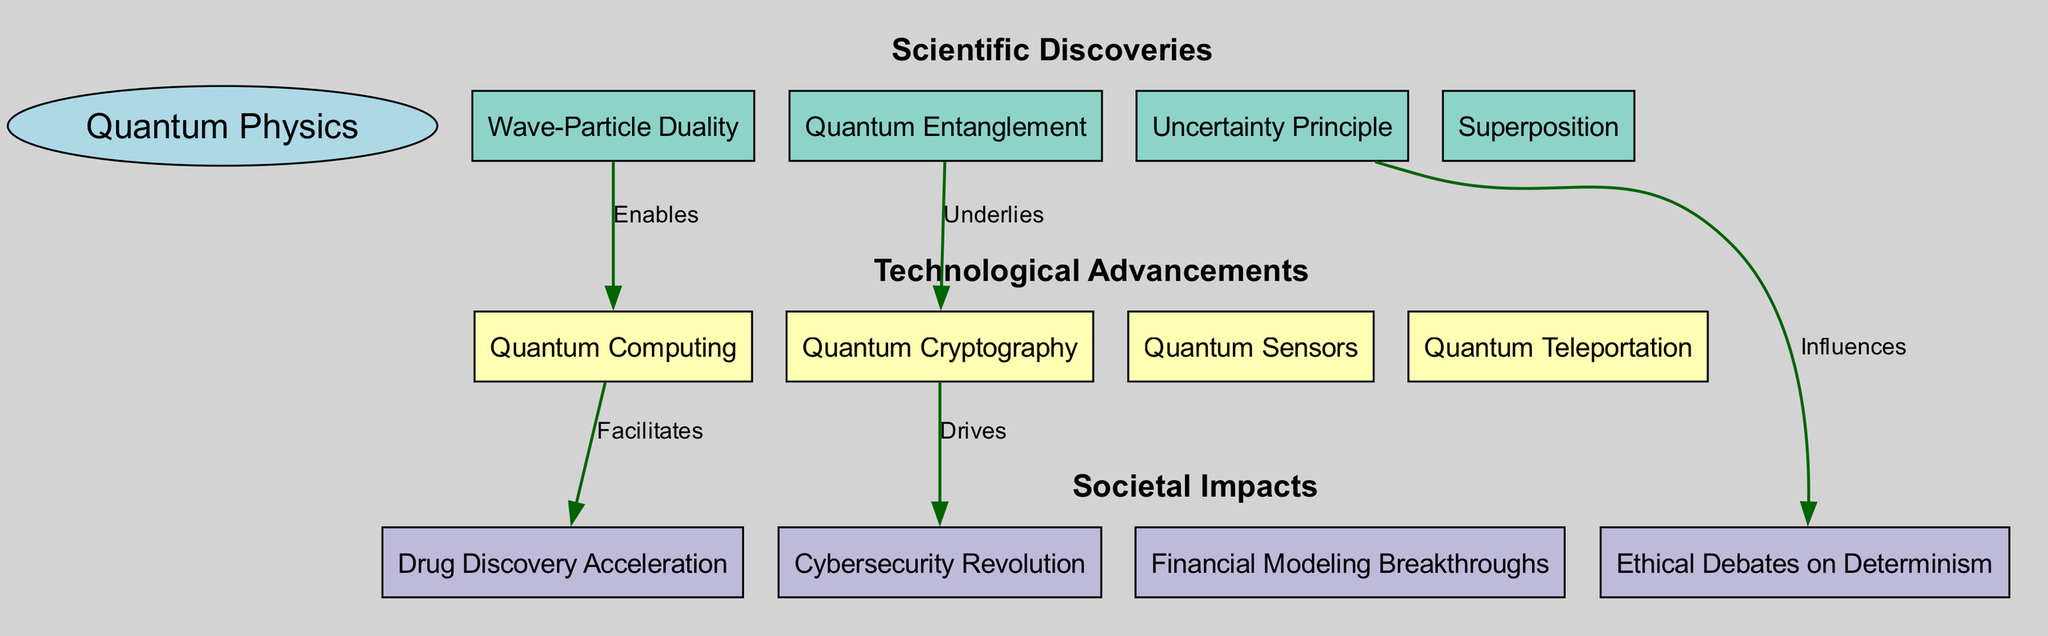What is the central concept depicted in the diagram? The central concept is labeled as "Quantum Physics" in the diagram, distinguishing it from other layers.
Answer: Quantum Physics How many nodes are there in the "Technological Advancements" layer? There are four nodes listed under the "Technological Advancements" layer: Quantum Computing, Quantum Cryptography, Quantum Sensors, and Quantum Teleportation.
Answer: Four Which discovery enables Quantum Computing? The connection from "Wave-Particle Duality" to "Quantum Computing" is labeled as "Enables," indicating that Wave-Particle Duality is the enabling scientific discovery for Quantum Computing.
Answer: Wave-Particle Duality What drives the Cybersecurity Revolution? The diagram shows an edge from "Quantum Cryptography" to "Cybersecurity Revolution" labeled as "Drives", meaning Quantum Cryptography is what drives this societal impact.
Answer: Quantum Cryptography Which principle influences ethical debates on determinism? There is a clear connection from "Uncertainty Principle" to "Ethical Debates on Determinism," indicating that the Uncertainty Principle has an influence on these debates.
Answer: Uncertainty Principle What is the relationship between Quantum Computing and Drug Discovery Acceleration? The relationship is represented by the edge from "Quantum Computing" to "Drug Discovery Acceleration," labeled as "Facilitates," which shows that Quantum Computing facilitates this societal impact.
Answer: Facilitates List two nodes in the "Scientific Discoveries" layer. The "Scientific Discoveries" layer includes the nodes "Wave-Particle Duality," "Uncertainty Principle," "Quantum Entanglement," and "Superposition." Two of these nodes can be any combination chosen, such as Wave-Particle Duality and Quantum Entanglement.
Answer: Wave-Particle Duality, Quantum Entanglement How many edges connect Scientific Discoveries to Technological Advancements? There are three edges identified that connect nodes in the "Scientific Discoveries" layer to nodes in the "Technological Advancements" layer: Wave-Particle Duality to Quantum Computing, Quantum Entanglement to Quantum Cryptography, and Uncertainty Principle. Therefore, the count is three edges.
Answer: Three edges What are the societal impacts associated with Quantum Cryptography? Quantum Cryptography is shown to drive the Cybersecurity Revolution; this demonstrates its direct relationship with this societal impact.
Answer: Cybersecurity Revolution 